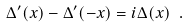<formula> <loc_0><loc_0><loc_500><loc_500>\Delta ^ { \prime } ( x ) - \Delta ^ { \prime } ( - x ) = i \Delta ( x ) \ .</formula> 